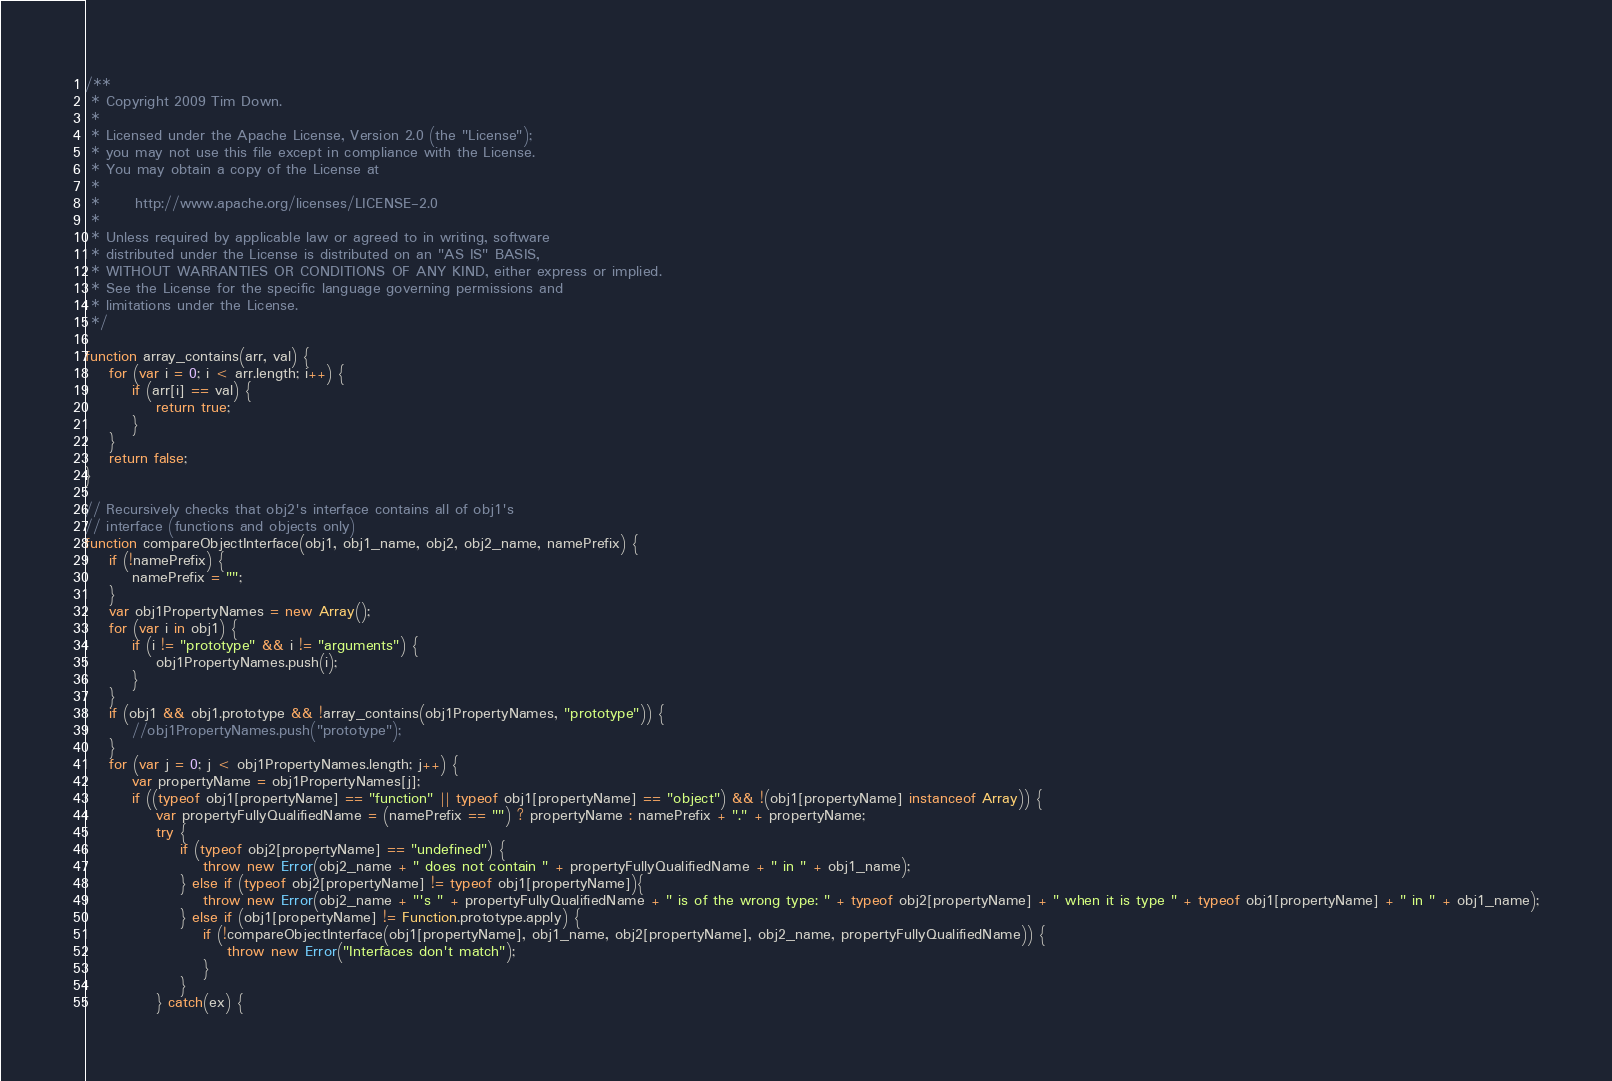<code> <loc_0><loc_0><loc_500><loc_500><_JavaScript_>/**
 * Copyright 2009 Tim Down.
 *
 * Licensed under the Apache License, Version 2.0 (the "License");
 * you may not use this file except in compliance with the License.
 * You may obtain a copy of the License at
 *
 *      http://www.apache.org/licenses/LICENSE-2.0
 *
 * Unless required by applicable law or agreed to in writing, software
 * distributed under the License is distributed on an "AS IS" BASIS,
 * WITHOUT WARRANTIES OR CONDITIONS OF ANY KIND, either express or implied.
 * See the License for the specific language governing permissions and
 * limitations under the License.
 */

function array_contains(arr, val) {
	for (var i = 0; i < arr.length; i++) {
		if (arr[i] == val) {
			return true;
		}
	}
	return false;
}

// Recursively checks that obj2's interface contains all of obj1's
// interface (functions and objects only)
function compareObjectInterface(obj1, obj1_name, obj2, obj2_name, namePrefix) {
	if (!namePrefix) {
		namePrefix = "";
	}
	var obj1PropertyNames = new Array();
	for (var i in obj1) {
		if (i != "prototype" && i != "arguments") {
			obj1PropertyNames.push(i);
		}
	}
	if (obj1 && obj1.prototype && !array_contains(obj1PropertyNames, "prototype")) {
		//obj1PropertyNames.push("prototype");
	}
	for (var j = 0; j < obj1PropertyNames.length; j++) {
		var propertyName = obj1PropertyNames[j];
		if ((typeof obj1[propertyName] == "function" || typeof obj1[propertyName] == "object") && !(obj1[propertyName] instanceof Array)) {
			var propertyFullyQualifiedName = (namePrefix == "") ? propertyName : namePrefix + "." + propertyName;
			try {
				if (typeof obj2[propertyName] == "undefined") {
					throw new Error(obj2_name + " does not contain " + propertyFullyQualifiedName + " in " + obj1_name);
				} else if (typeof obj2[propertyName] != typeof obj1[propertyName]){
					throw new Error(obj2_name + "'s " + propertyFullyQualifiedName + " is of the wrong type: " + typeof obj2[propertyName] + " when it is type " + typeof obj1[propertyName] + " in " + obj1_name);
				} else if (obj1[propertyName] != Function.prototype.apply) {
					if (!compareObjectInterface(obj1[propertyName], obj1_name, obj2[propertyName], obj2_name, propertyFullyQualifiedName)) {
						throw new Error("Interfaces don't match");
					}
				}
			} catch(ex) {</code> 